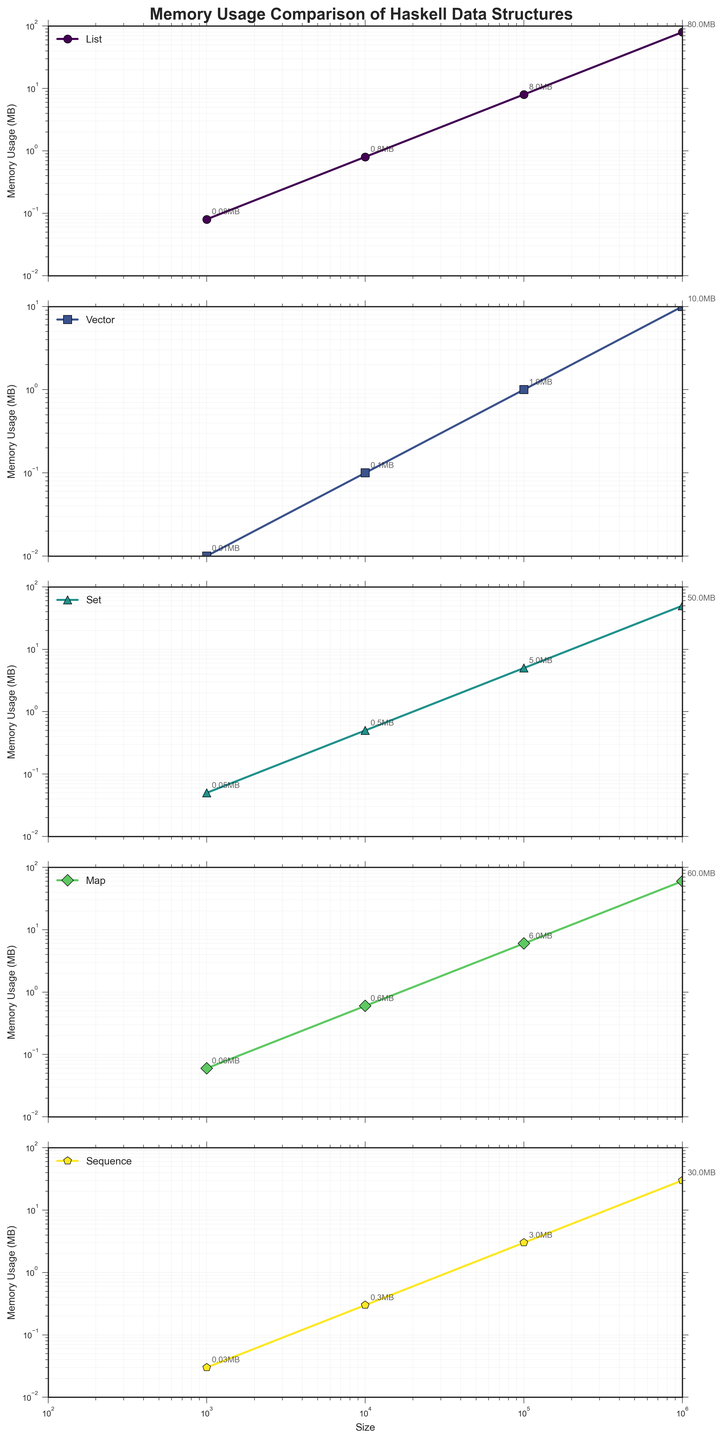How does the memory usage of a list compare to a vector for a size of 100,000? Locate the "List" and "Vector" lines on the figure for a size of 100,000. The List has a memory usage of 8.0 MB, whereas the Vector has 1.0 MB.
Answer: A list uses more memory than a vector What is the proportion difference in memory usage between a Set and a Map at size 1,000,000? Identify the memory usage for both Set (50.0 MB) and Map (60.0 MB) at size 1,000,000. The proportion difference is (60.0 - 50.0) / 50.0 = 0.2
Answer: 20% Which data structure uses the least memory for a size of 10,000? Compare the memory usage of all data structures at size 10,000: List (0.8 MB), Vector (0.1 MB), Set (0.5 MB), Map (0.6 MB), Sequence (0.3 MB). Vector has the lowest memory usage.
Answer: Vector At size 1,000, which data structure has the closest memory usage to a Sequence? Look for the memory usage values for all structures at size 1,000: Sequence (0.03 MB). The closest is Vector with 0.01 MB, List with 0.08 MB, Set with 0.05 MB, Map with 0.06 MB.
Answer: Set Which data structure shows the greatest rate of increase in memory usage as size increases from 1,000 to 1,000,000? Calculate the rate of increase for memory usage over the range for each structure: List (0.08->80.0, rate: 999), Vector (0.01->10.0, rate: 999), Set (0.05->50.0, rate: 999), Map (0.06->60.0, rate: 999), Sequence (0.03->30.0, rate: 999).
Answer: All have the same rate How many times more memory does a List use compared to a Sequence at size 100,000? Check the memory usage values for List (8.0 MB) and Sequence (3.0 MB) at size 100,000. The memory usage of List is 8.0 / 3.0 = 2.67 times more than Sequence.
Answer: 2.67 times If you combine the memory usage of a Map and a Vector at size 10,000, what is the total memory usage? Find and sum the values for Map (0.6 MB) and Vector (0.1 MB) at size 10,000. The total is 0.6 + 0.1 = 0.7 MB.
Answer: 0.7 MB 